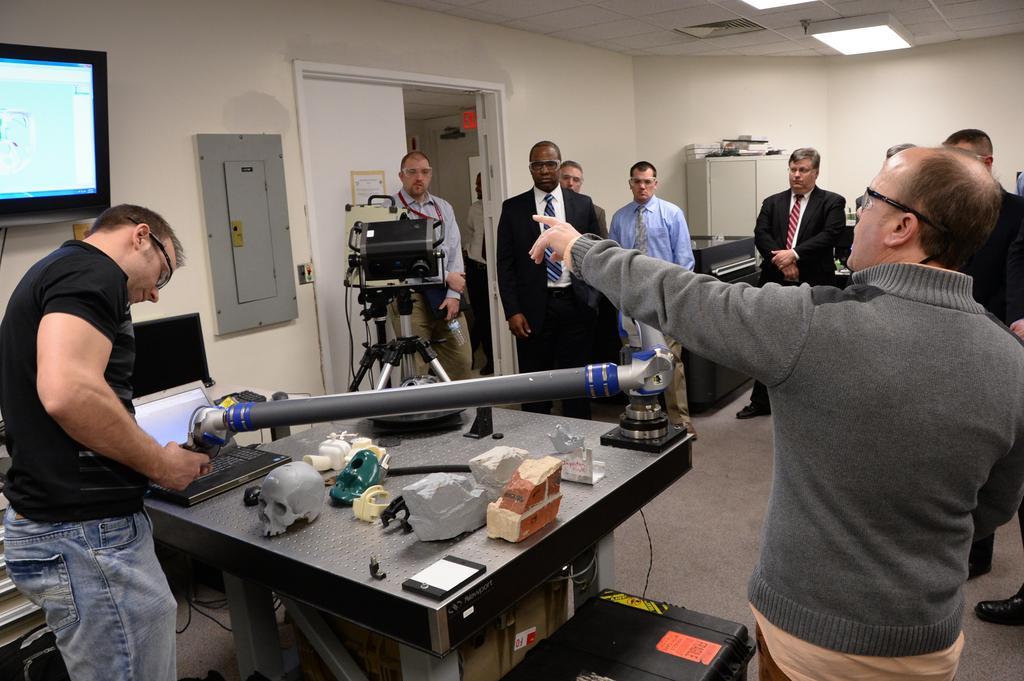Please provide a concise description of this image. As we can see in the image there is a white color wall, door, screen, few people here and there and in the middle there is a electrical equipment and there is a table over here. On table there is a skeleton head, laptop, stone, mobile phone and some electrical equipment. 